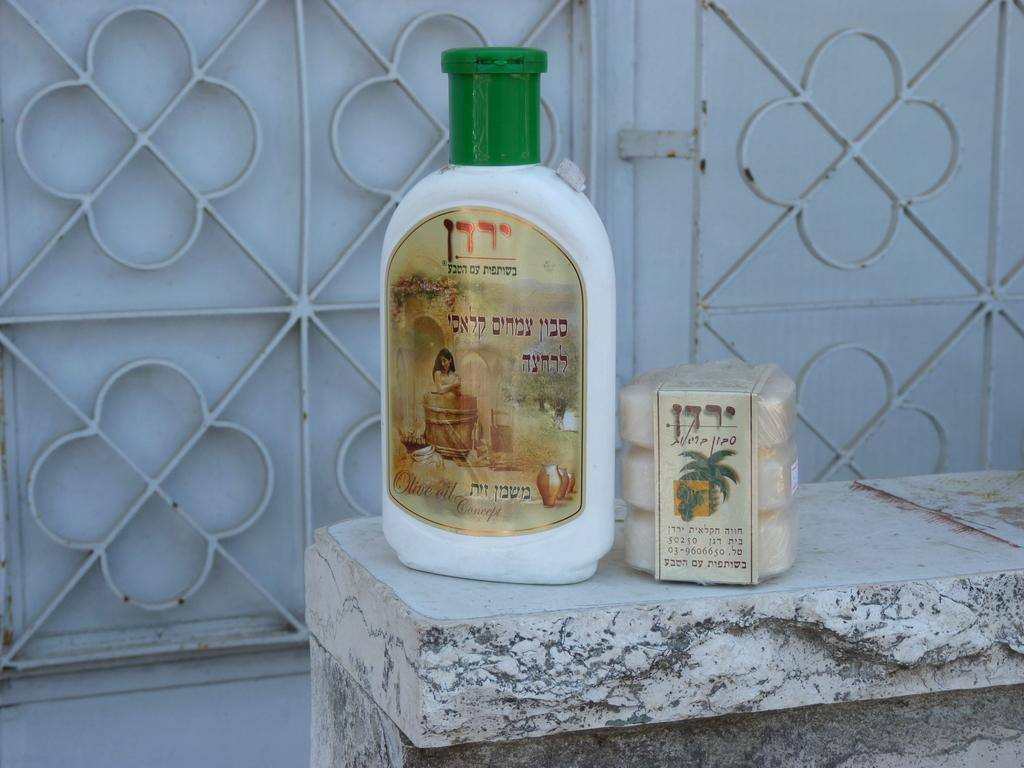What is the color of the bottle in the image? The bottle in the image is white with a green cap. Where is the bottle located in the image? The bottle is placed on a wall. What other item can be seen in the image related to cleanliness? There is a soap in the image. What is written on the soap? The soap has something written on it. Where is the soap placed in the image? The soap is also placed on the wall. What type of hat is the tiger wearing in the image? There is no tiger or hat present in the image. What time does the watch show in the image? There is no watch present in the image. 